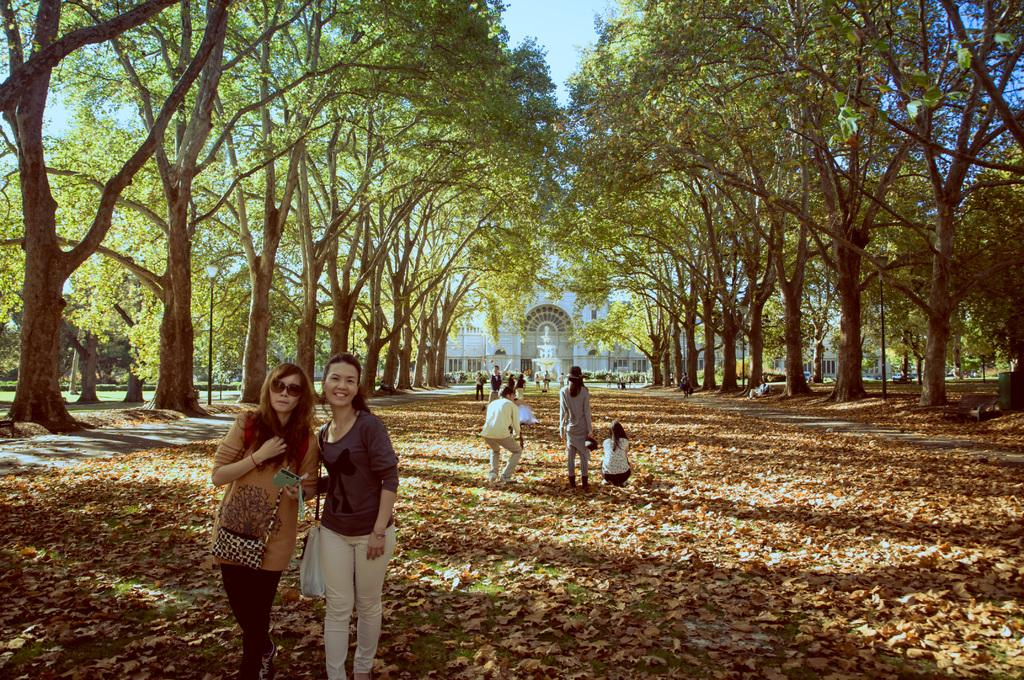Who or what can be seen in the image? There are people in the image. What type of natural elements are present in the image? There are trees in the image. What type of structure is visible in the background? There is a building in the background of the image. What type of debris can be seen at the bottom of the image? Dry leaves are present at the bottom of the image. How many kittens are playing with the zipper in the image? There are no kittens or zippers present in the image. What type of payment is being made in the image? There is no payment being made in the image. 